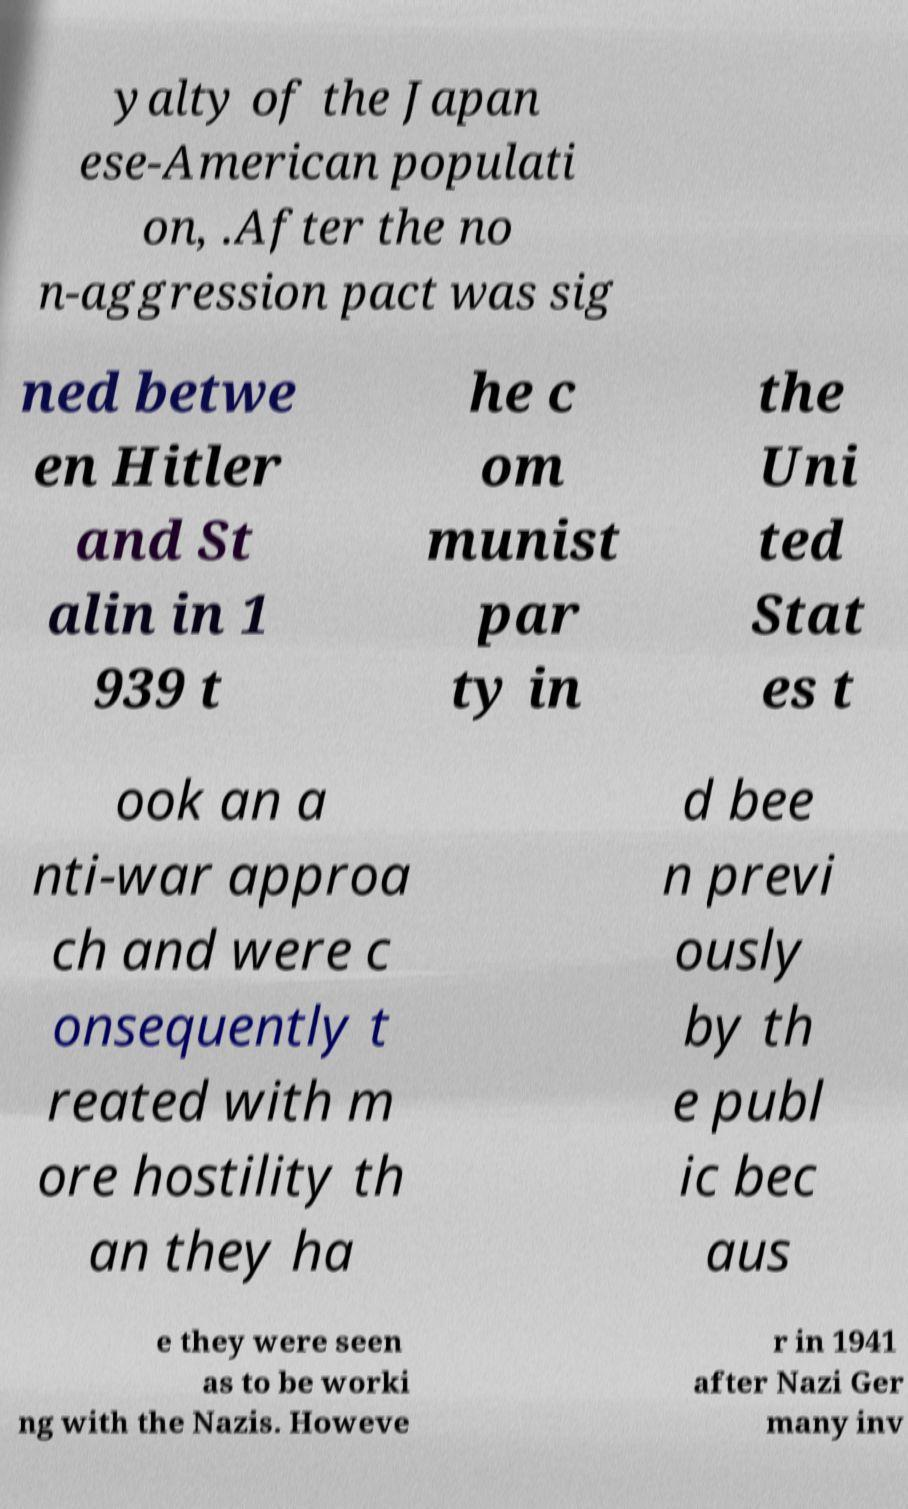What messages or text are displayed in this image? I need them in a readable, typed format. yalty of the Japan ese-American populati on, .After the no n-aggression pact was sig ned betwe en Hitler and St alin in 1 939 t he c om munist par ty in the Uni ted Stat es t ook an a nti-war approa ch and were c onsequently t reated with m ore hostility th an they ha d bee n previ ously by th e publ ic bec aus e they were seen as to be worki ng with the Nazis. Howeve r in 1941 after Nazi Ger many inv 